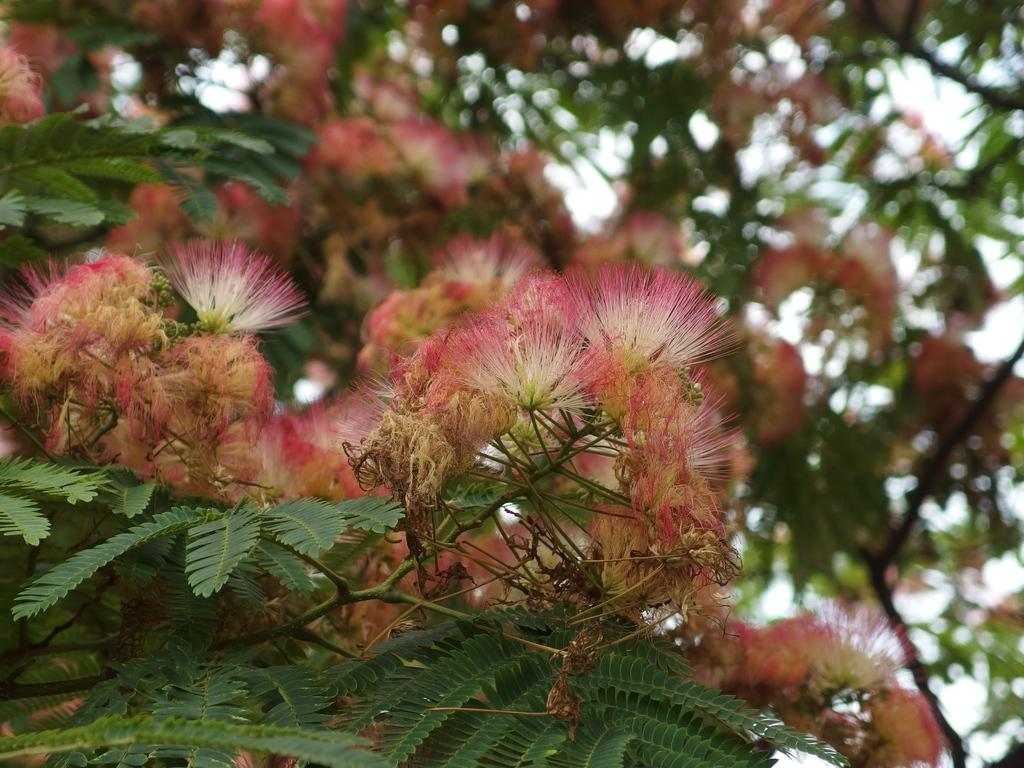What type of plant life is present in the image? There are flowers, leaves, and stems in the image. Can you describe the background of the image? The sky is visible in the background of the image. What sound can be heard coming from the flowers in the image? There is no sound coming from the flowers in the image, as flowers do not produce sound. 